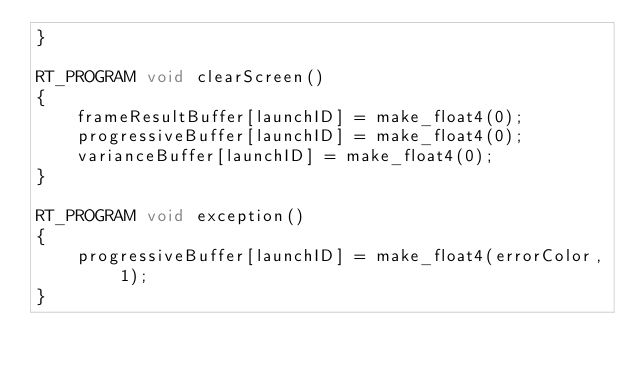<code> <loc_0><loc_0><loc_500><loc_500><_Cuda_>}

RT_PROGRAM void clearScreen()
{
    frameResultBuffer[launchID] = make_float4(0);
    progressiveBuffer[launchID] = make_float4(0);
    varianceBuffer[launchID] = make_float4(0);
}

RT_PROGRAM void exception()
{
    progressiveBuffer[launchID] = make_float4(errorColor, 1);
}</code> 